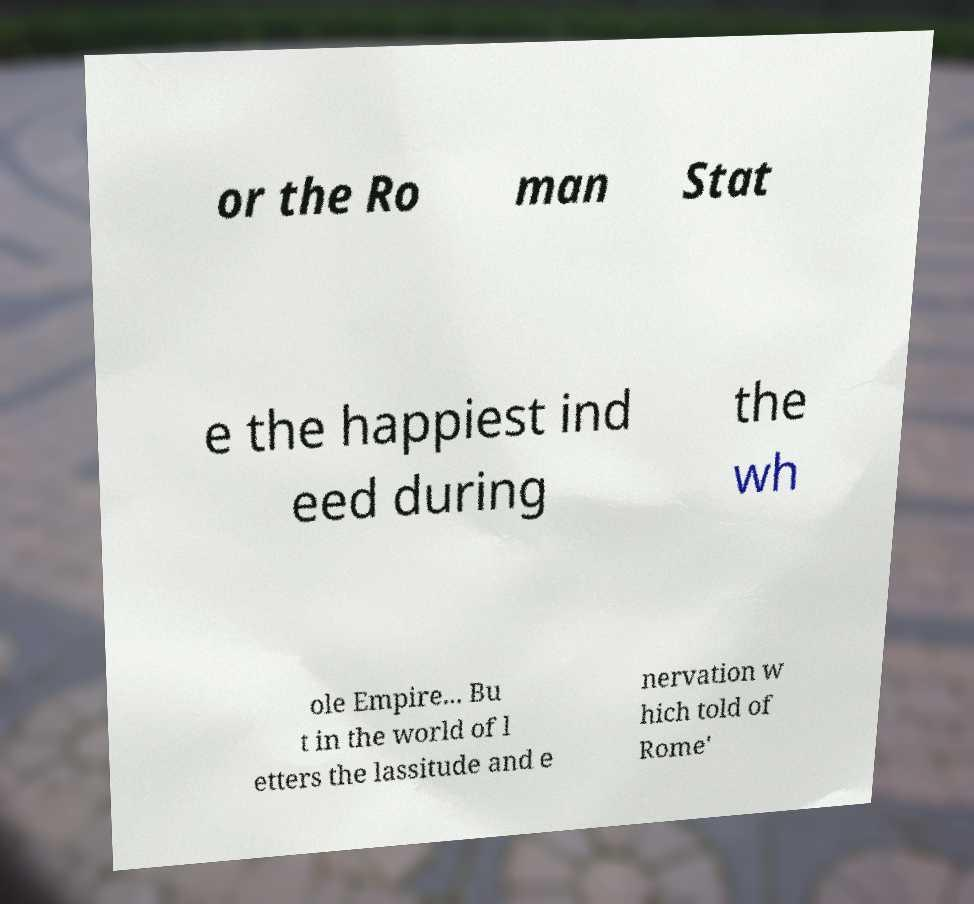I need the written content from this picture converted into text. Can you do that? or the Ro man Stat e the happiest ind eed during the wh ole Empire... Bu t in the world of l etters the lassitude and e nervation w hich told of Rome' 